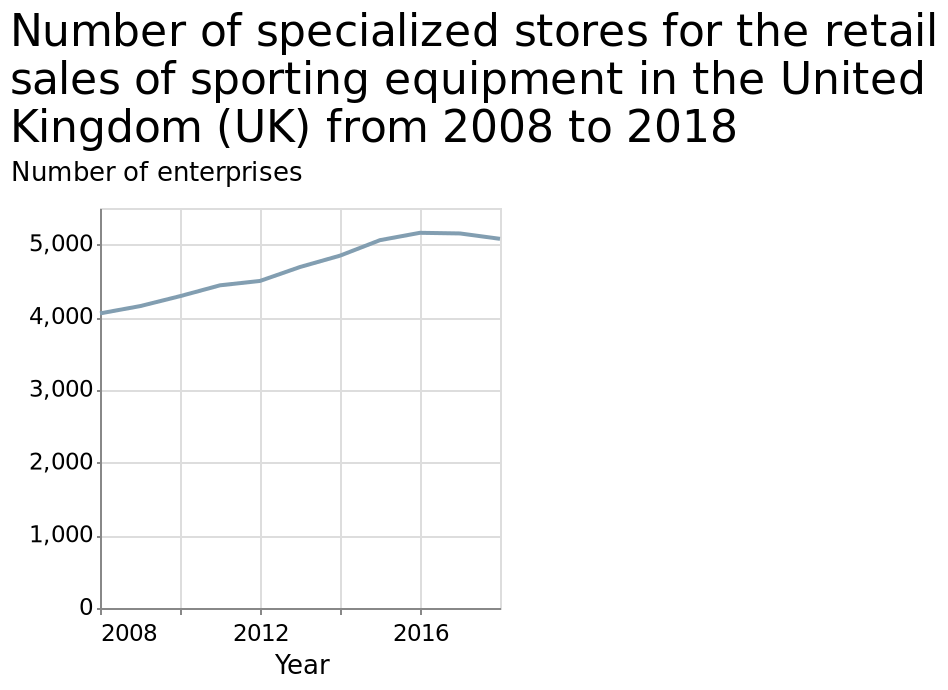<image>
During which years did the increase in specialized stores for retail sales of sporting equipment occur in the UK?  The increase in specialized stores for retail sales of sporting equipment occurred between 2008 and 2016 in the UK. What type of stores saw an increase in numbers in the UK between 2008 and 2016?  Specialized stores for the retail sales of sporting equipment saw an increase in numbers in the UK between 2008 and 2016. 